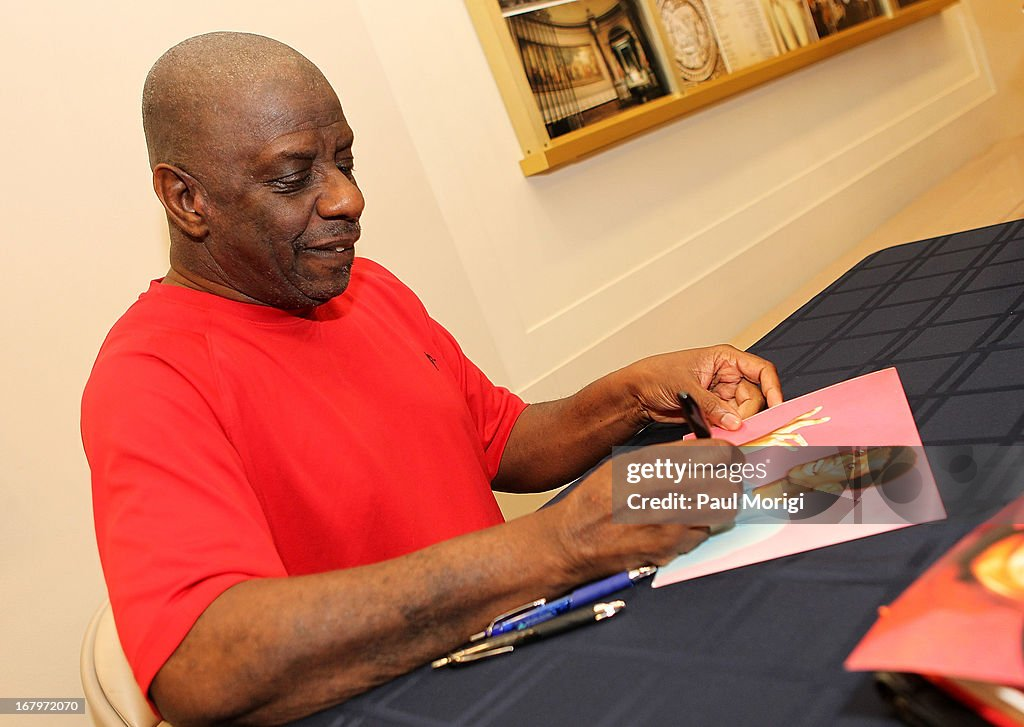What might be the historical significance if this event was a signing of an important cultural document? If this event was the signing of an important cultural document, it could signify a momentous occasion in preserving and promoting cultural heritage. The document might include agreements or declarations supporting the arts, protecting historical sites, or recognizing significant cultural contributions. This event's historical significance would be in its role in fostering and preserving cultural identity and heritage for future generations, marking a pivotal moment of acknowledgment and appreciation in cultural history. Can you describe the emotional atmosphere at such an event? An event centered around the signing of an important cultural document would likely be filled with a sense of pride and reverence. Attendees might feel a deep connection to their heritage and gratitude towards the individual responsible for this recognition. The atmosphere would be a blend of solemn respect for the cultural significance and a celebratory mood, highlighting the collective achievement and the preservation efforts. This mixture of emotions would make the event both uplifting and historically profound. 